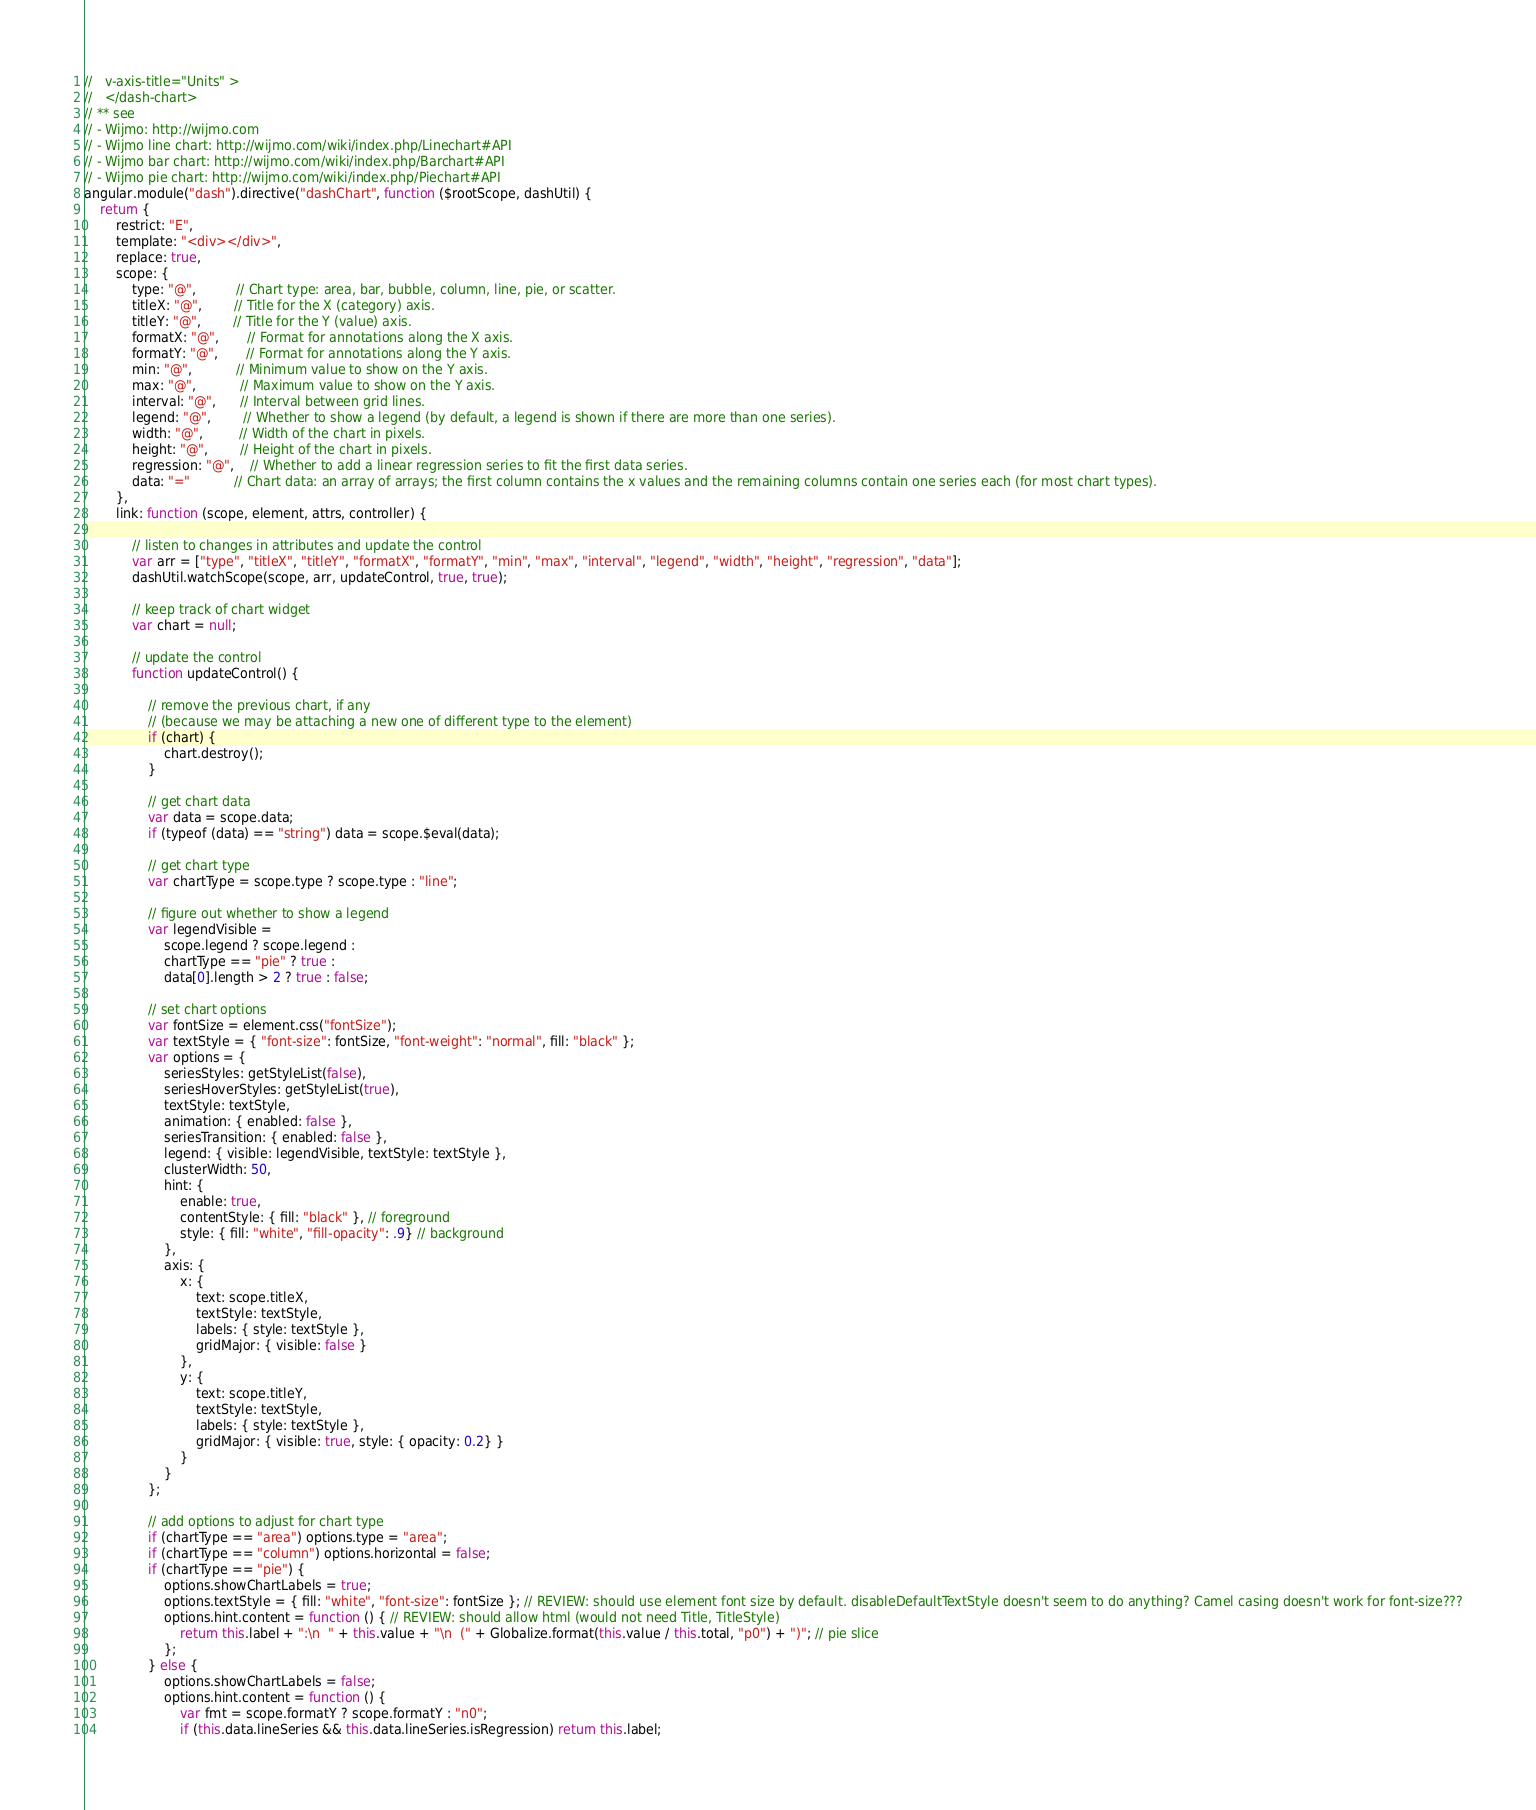Convert code to text. <code><loc_0><loc_0><loc_500><loc_500><_JavaScript_>//   v-axis-title="Units" >
//   </dash-chart>
// ** see
// - Wijmo: http://wijmo.com
// - Wijmo line chart: http://wijmo.com/wiki/index.php/Linechart#API
// - Wijmo bar chart: http://wijmo.com/wiki/index.php/Barchart#API
// - Wijmo pie chart: http://wijmo.com/wiki/index.php/Piechart#API
angular.module("dash").directive("dashChart", function ($rootScope, dashUtil) {
    return {
        restrict: "E",
        template: "<div></div>",
        replace: true,
        scope: {
            type: "@",          // Chart type: area, bar, bubble, column, line, pie, or scatter.
            titleX: "@",        // Title for the X (category) axis.
            titleY: "@",        // Title for the Y (value) axis.
            formatX: "@",       // Format for annotations along the X axis.
            formatY: "@",       // Format for annotations along the Y axis.
            min: "@",           // Minimum value to show on the Y axis.
            max: "@",           // Maximum value to show on the Y axis.
            interval: "@",      // Interval between grid lines.
            legend: "@",        // Whether to show a legend (by default, a legend is shown if there are more than one series).
            width: "@",         // Width of the chart in pixels.
            height: "@",        // Height of the chart in pixels.
            regression: "@",    // Whether to add a linear regression series to fit the first data series.
            data: "="           // Chart data: an array of arrays; the first column contains the x values and the remaining columns contain one series each (for most chart types).
        },
        link: function (scope, element, attrs, controller) {

            // listen to changes in attributes and update the control
            var arr = ["type", "titleX", "titleY", "formatX", "formatY", "min", "max", "interval", "legend", "width", "height", "regression", "data"];
            dashUtil.watchScope(scope, arr, updateControl, true, true);

            // keep track of chart widget
            var chart = null;

            // update the control
            function updateControl() {

                // remove the previous chart, if any
                // (because we may be attaching a new one of different type to the element)
                if (chart) {
                    chart.destroy();
                }

                // get chart data
                var data = scope.data;
                if (typeof (data) == "string") data = scope.$eval(data);

                // get chart type
                var chartType = scope.type ? scope.type : "line";

                // figure out whether to show a legend
                var legendVisible =
                    scope.legend ? scope.legend :
                    chartType == "pie" ? true :
                    data[0].length > 2 ? true : false;

                // set chart options
                var fontSize = element.css("fontSize");
                var textStyle = { "font-size": fontSize, "font-weight": "normal", fill: "black" };
                var options = {
                    seriesStyles: getStyleList(false),
                    seriesHoverStyles: getStyleList(true),
                    textStyle: textStyle,
                    animation: { enabled: false },
                    seriesTransition: { enabled: false },
                    legend: { visible: legendVisible, textStyle: textStyle },
                    clusterWidth: 50,
                    hint: {
                        enable: true,
                        contentStyle: { fill: "black" }, // foreground
                        style: { fill: "white", "fill-opacity": .9} // background
                    },
                    axis: {
                        x: {
                            text: scope.titleX,
                            textStyle: textStyle,
                            labels: { style: textStyle },
                            gridMajor: { visible: false }
                        },
                        y: {
                            text: scope.titleY,
                            textStyle: textStyle,
                            labels: { style: textStyle },
                            gridMajor: { visible: true, style: { opacity: 0.2} }
                        }
                    }
                };

                // add options to adjust for chart type
                if (chartType == "area") options.type = "area";
                if (chartType == "column") options.horizontal = false;
                if (chartType == "pie") {
                    options.showChartLabels = true;
                    options.textStyle = { fill: "white", "font-size": fontSize }; // REVIEW: should use element font size by default. disableDefaultTextStyle doesn't seem to do anything? Camel casing doesn't work for font-size???
                    options.hint.content = function () { // REVIEW: should allow html (would not need Title, TitleStyle)
                        return this.label + ":\n  " + this.value + "\n  (" + Globalize.format(this.value / this.total, "p0") + ")"; // pie slice
                    };
                } else {
                    options.showChartLabels = false;
                    options.hint.content = function () {
                        var fmt = scope.formatY ? scope.formatY : "n0";
                        if (this.data.lineSeries && this.data.lineSeries.isRegression) return this.label;</code> 